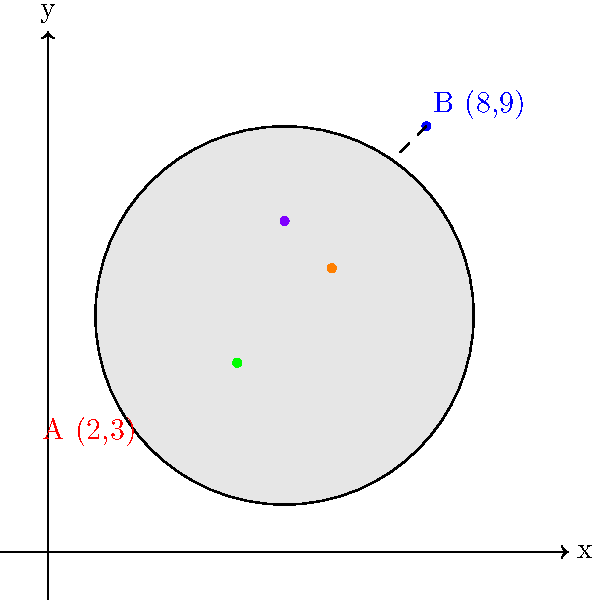As a meticulous food critic, you're analyzing the presentation of a new avant-garde dish. The chef claims that the precise spacing between ingredients is crucial to the flavor profile. On a coordinate plane representing the plate, two key ingredients are located at points A(2,3) and B(8,9). Calculate the exact distance between these two ingredients to determine if the chef's claim about precision holds merit. To find the distance between two points on a coordinate plane, we use the distance formula, which is derived from the Pythagorean theorem:

$$d = \sqrt{(x_2 - x_1)^2 + (y_2 - y_1)^2}$$

Where $(x_1, y_1)$ are the coordinates of the first point and $(x_2, y_2)$ are the coordinates of the second point.

Given:
Point A: $(x_1, y_1) = (2, 3)$
Point B: $(x_2, y_2) = (8, 9)$

Let's solve this step-by-step:

1) Substitute the values into the formula:
   $$d = \sqrt{(8 - 2)^2 + (9 - 3)^2}$$

2) Simplify inside the parentheses:
   $$d = \sqrt{6^2 + 6^2}$$

3) Calculate the squares:
   $$d = \sqrt{36 + 36}$$

4) Add inside the square root:
   $$d = \sqrt{72}$$

5) Simplify the square root:
   $$d = 6\sqrt{2}$$

This is the exact distance between the two ingredients. If we wanted to express it as a decimal approximation, we could calculate:

$$6\sqrt{2} \approx 8.49$$

The exact distance allows for a more precise critique of the chef's claims about ingredient spacing.
Answer: $6\sqrt{2}$ units 